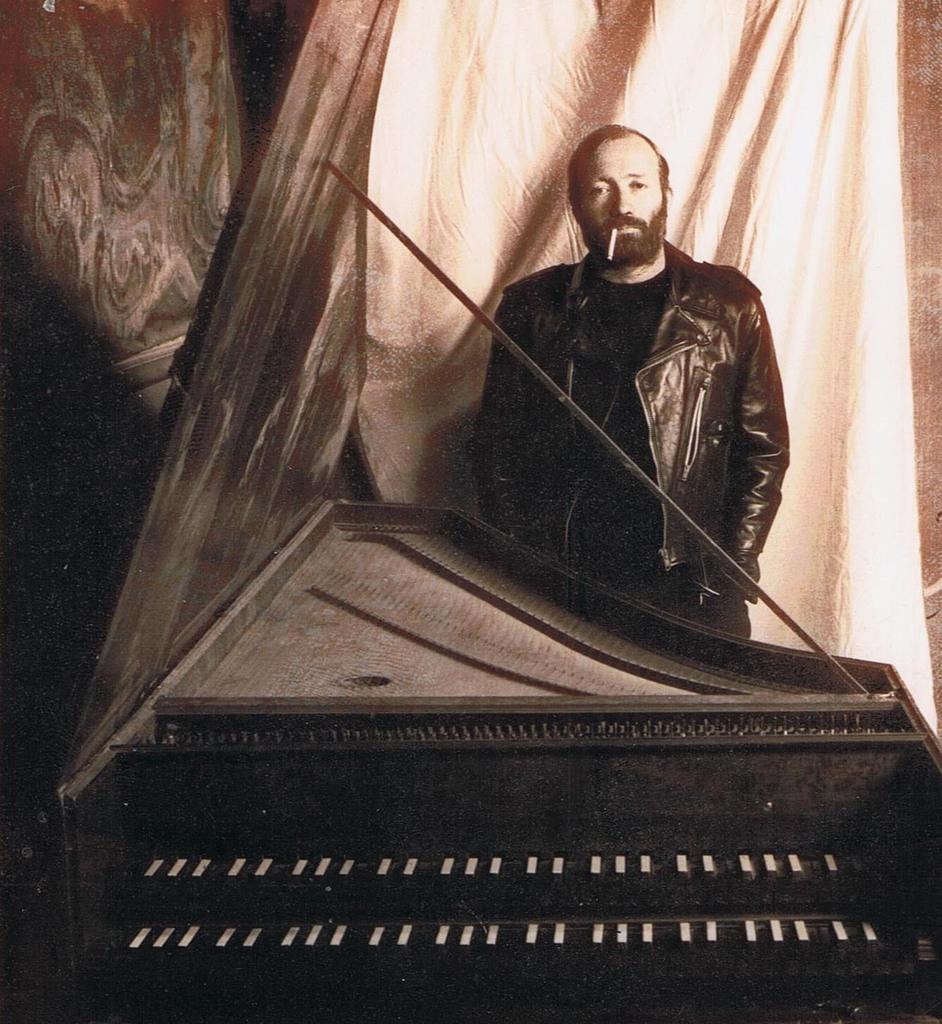Who or what is the main subject in the image? There is a person in the image. What is the person wearing? The person is wearing a jacket. What is the person holding or doing with their mouth? The person has a cigarette in their mouth. What object is in front of the person? There is a piano in front of the person. What is visible behind the person? There is a curtain behind the person. What type of bee can be seen buzzing around the person's head in the image? There is no bee present in the image. What color is the feather that the person is using to play the piano? There is no feather visible in the image; the person is using their hands to play the piano. 